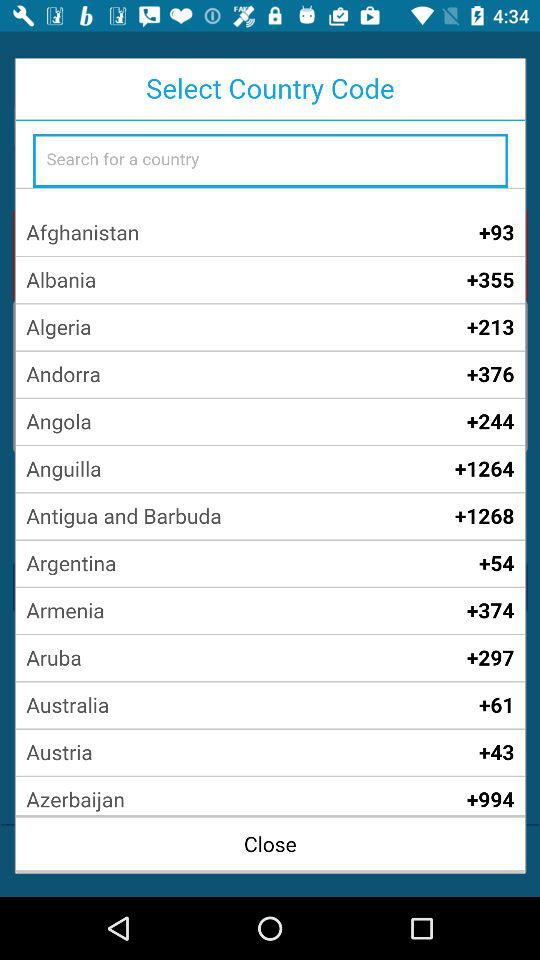What country has the +61 code? The country's name is "Australia". 